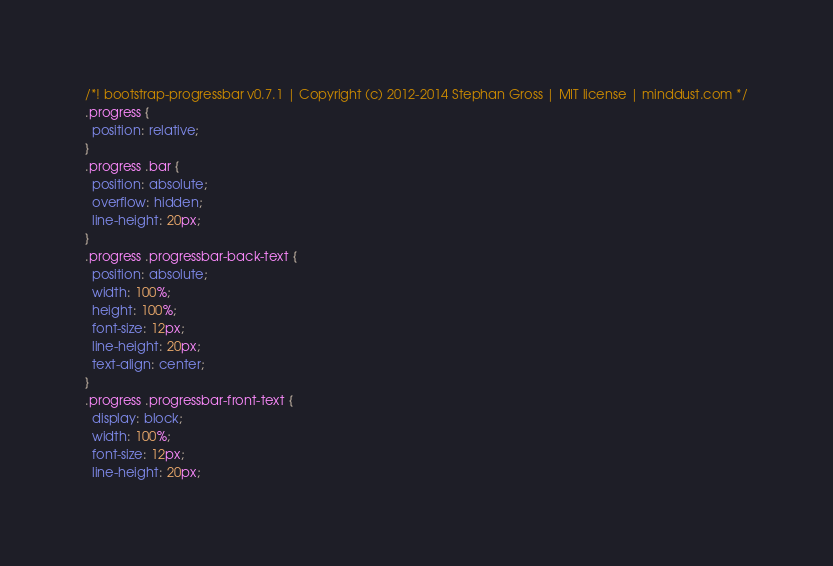Convert code to text. <code><loc_0><loc_0><loc_500><loc_500><_CSS_>/*! bootstrap-progressbar v0.7.1 | Copyright (c) 2012-2014 Stephan Gross | MIT license | minddust.com */
.progress {
  position: relative;
}
.progress .bar {
  position: absolute;
  overflow: hidden;
  line-height: 20px;
}
.progress .progressbar-back-text {
  position: absolute;
  width: 100%;
  height: 100%;
  font-size: 12px;
  line-height: 20px;
  text-align: center;
}
.progress .progressbar-front-text {
  display: block;
  width: 100%;
  font-size: 12px;
  line-height: 20px;</code> 